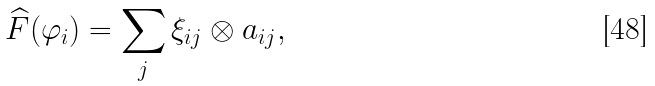<formula> <loc_0><loc_0><loc_500><loc_500>\widehat { F } ( \varphi _ { i } ) = \sum _ { j } \xi _ { i j } \otimes a _ { i j } ,</formula> 